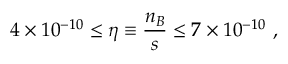<formula> <loc_0><loc_0><loc_500><loc_500>4 \times 1 0 ^ { - 1 0 } \leq \eta \equiv \frac { n _ { B } } { s } \leq 7 \times 1 0 ^ { - 1 0 } \ ,</formula> 